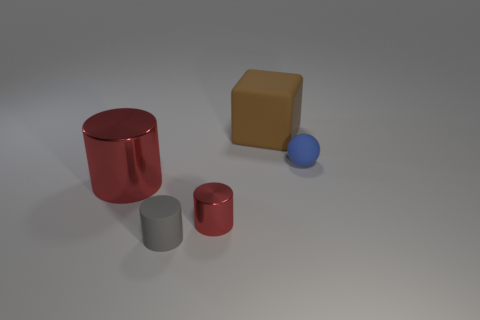Is the number of small red metal cylinders greater than the number of large gray matte cylinders?
Your answer should be very brief. Yes. What number of objects are red cylinders to the right of the big cylinder or rubber things that are on the right side of the large red shiny object?
Your response must be concise. 4. There is a metal object that is the same size as the cube; what is its color?
Offer a very short reply. Red. Is the material of the gray cylinder the same as the small red object?
Your answer should be very brief. No. There is a small object that is behind the large object that is on the left side of the big brown cube; what is it made of?
Give a very brief answer. Rubber. Are there more small blue rubber spheres right of the rubber cylinder than tiny gray matte objects?
Provide a short and direct response. No. What number of other things are there of the same size as the sphere?
Your answer should be compact. 2. Do the big shiny thing and the tiny metal thing have the same color?
Provide a short and direct response. Yes. The tiny cylinder that is behind the tiny matte thing that is on the left side of the thing that is behind the tiny blue rubber sphere is what color?
Offer a very short reply. Red. There is a tiny rubber thing that is in front of the small thing that is on the right side of the big brown matte cube; what number of small things are to the right of it?
Offer a very short reply. 2. 